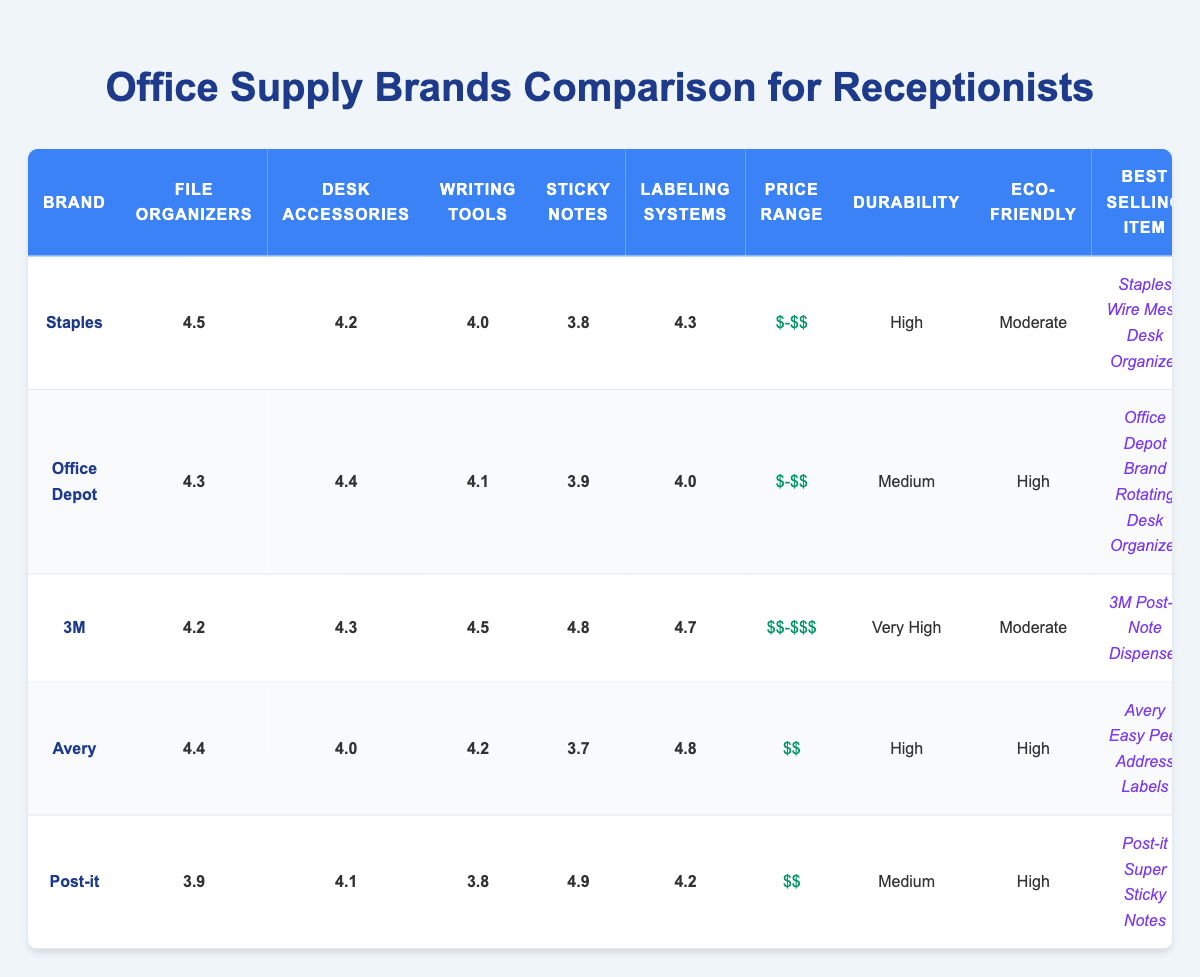What is the best selling item for Office Depot? The table lists "Office Depot Brand Rotating Desk Organizer" as the best selling item in the row for Office Depot.
Answer: Office Depot Brand Rotating Desk Organizer Which brand has the highest sticky notes rating? The sticky notes ratings for each brand are: Staples - 3.8, Office Depot - 3.9, 3M - 4.8, Avery - 3.7, Post-it - 4.9. Post-it has the highest rating of 4.9.
Answer: Post-it What is the average durability rating for all brands? The durability ratings are: Staples - High, Office Depot - Medium, 3M - Very High, Avery - High, Post-it - Medium. Converting these ratings to numerical values (High = 3, Medium = 2, Very High = 4), we have: 3 + 2 + 4 + 3 + 2 = 14. There are 5 brands, so the average is 14/5 = 2.8, which translates back to approximately "Medium" on a qualitative scale.
Answer: Medium Does Avery have an eco-friendly rating of High? Yes, the table indicates that Avery has an eco-friendly score of High.
Answer: Yes Which brand offers the cheapest price range? The price ranges for comparison are as follows: Staples - $-$$, Office Depot - $-$$, 3M - $$-$$$, Avery - $$, Post-it - $$. The brands Staples and Office Depot both have the lowest price range of $-$$.
Answer: Staples and Office Depot Which brand has the lowest file organizers rating? The file organizers ratings for brands are: Staples - 4.5, Office Depot - 4.3, 3M - 4.2, Avery - 4.4, Post-it - 3.9. Post-it has the lowest rating of 3.9.
Answer: Post-it What is the difference between the sticky notes ratings of 3M and Post-it? The sticky notes ratings are: 3M - 4.8 and Post-it - 4.9. The difference is 4.9 - 4.8 = 0.1, meaning Post-it has a higher rating by 0.1.
Answer: 0.1 Which brand has a labeling systems rating of 4.0 or higher? Looking at the labeling systems ratings: Staples - 4.3, Office Depot - 4.0, 3M - 4.7, Avery - 4.8, Post-it - 4.2. All brands except Office Depot have a rating of 4.0 or higher.
Answer: Staples, 3M, Avery, Post-it 